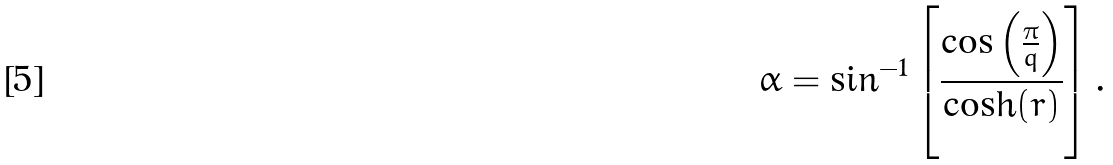<formula> <loc_0><loc_0><loc_500><loc_500>\alpha = \sin ^ { - 1 } \left [ \frac { \cos \left ( \frac { \pi } { q } \right ) } { \cosh ( r ) } \right ] .</formula> 